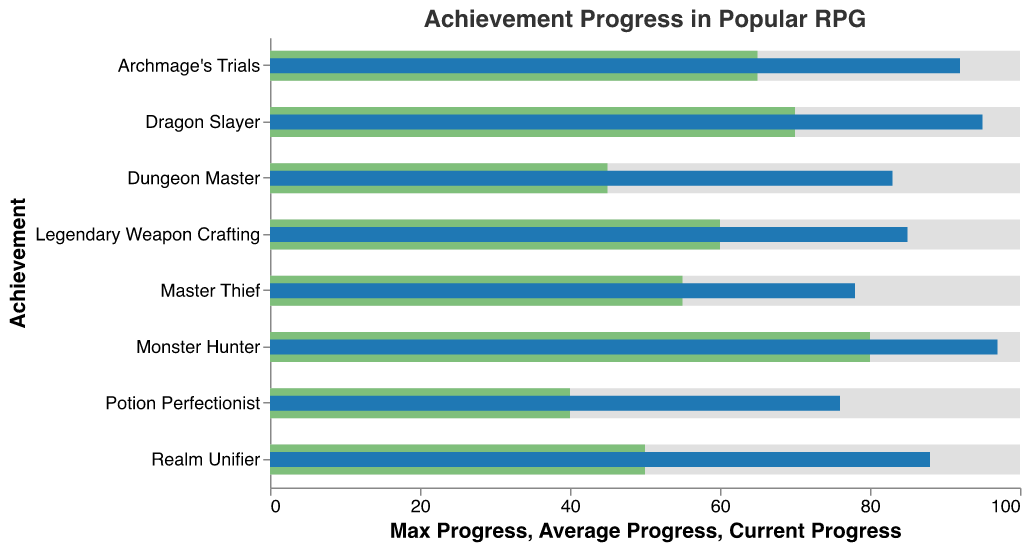What is the title of the figure? The title is located at the top of the figure, indicating the main focus or subject of the chart.
Answer: Achievement Progress in Popular RPG How many different achievements are presented in the chart? By observing the y-axis labels, we can count the unique achievements listed.
Answer: 8 Which achievement shows the highest current progress? We compare the lengths of the current progress bars (blue) for each achievement. The longest bar indicates the highest current progress.
Answer: Monster Hunter Which achievement has the largest gap between current progress and average progress? To find this, we calculate the difference between the current progress and average progress for each achievement and identify the largest difference.
Answer: Monster Hunter Which achievements have a current progress of over 90%? We identify the achievements with current progress bars (blue) extending beyond the 90 mark on the x-axis.
Answer: Dragon Slayer, Archmage's Trials, Monster Hunter What is the average progress for Archmage's Trials? By looking at the y-axis label for Archmage's Trials and then referring to the light green bar's endpoint on the x-axis.
Answer: 65 For the achievement "Realm Unifier," what is the difference between current progress and average progress? We calculate the difference by subtracting the endpoint of the average progress bar (light green) from the endpoint of the current progress bar (blue) for "Realm Unifier."
Answer: 38 How does your current progress in Master Thief compare to the game-wide average? We compare the lengths of the current progress bar (blue) and average progress bar (light green) specifically for "Master Thief."
Answer: Higher What is the range for the average progress across all achievements? We find the minimum and maximum endpoints of the average progress bars (light green) across all achievements and calculate the range by subtracting the minimum from the maximum.
Answer: 40 Which achievement has the smallest gap between current progress and max progress? This requires checking which achievement's current progress bar (blue) is closest to the max progress boundary (100) and finding the smallest difference.
Answer: Monster Hunter 